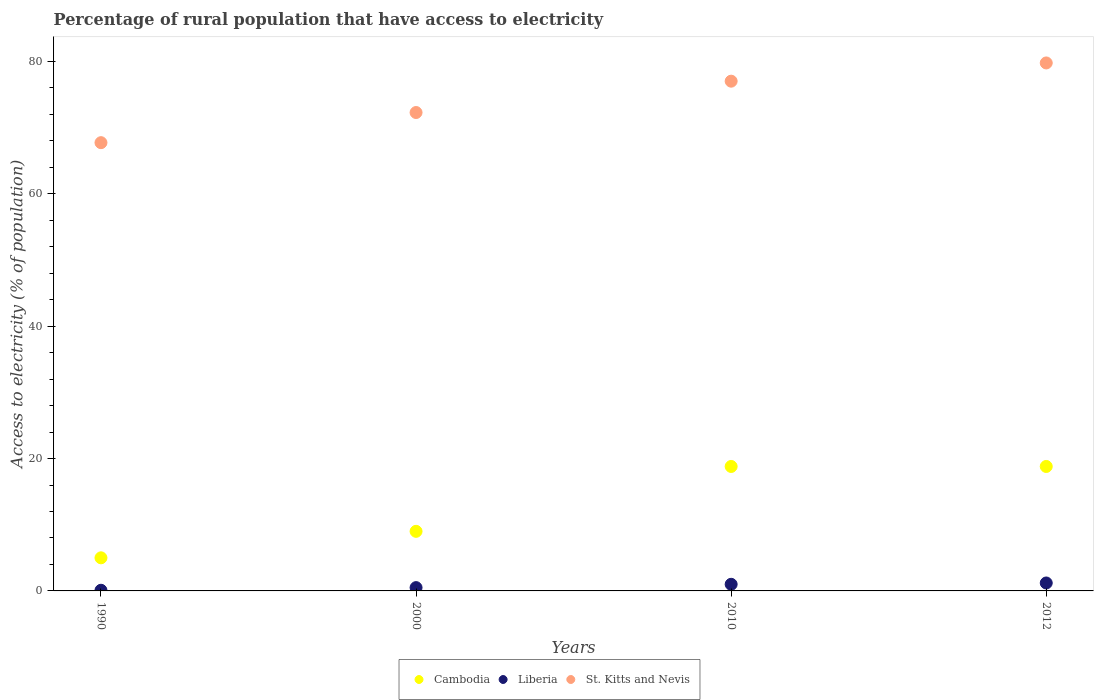How many different coloured dotlines are there?
Ensure brevity in your answer.  3. Across all years, what is the minimum percentage of rural population that have access to electricity in Liberia?
Your answer should be very brief. 0.1. In which year was the percentage of rural population that have access to electricity in Cambodia maximum?
Offer a very short reply. 2010. What is the total percentage of rural population that have access to electricity in St. Kitts and Nevis in the graph?
Your answer should be very brief. 296.73. What is the difference between the percentage of rural population that have access to electricity in St. Kitts and Nevis in 1990 and that in 2010?
Make the answer very short. -9.29. What is the difference between the percentage of rural population that have access to electricity in Cambodia in 1990 and the percentage of rural population that have access to electricity in St. Kitts and Nevis in 2000?
Your answer should be very brief. -67.27. What is the average percentage of rural population that have access to electricity in St. Kitts and Nevis per year?
Give a very brief answer. 74.18. In the year 2010, what is the difference between the percentage of rural population that have access to electricity in Liberia and percentage of rural population that have access to electricity in Cambodia?
Your answer should be compact. -17.8. In how many years, is the percentage of rural population that have access to electricity in Cambodia greater than 72 %?
Offer a terse response. 0. Is the difference between the percentage of rural population that have access to electricity in Liberia in 1990 and 2012 greater than the difference between the percentage of rural population that have access to electricity in Cambodia in 1990 and 2012?
Provide a short and direct response. Yes. What is the difference between the highest and the lowest percentage of rural population that have access to electricity in St. Kitts and Nevis?
Ensure brevity in your answer.  12.04. Does the percentage of rural population that have access to electricity in Cambodia monotonically increase over the years?
Give a very brief answer. No. Is the percentage of rural population that have access to electricity in Liberia strictly greater than the percentage of rural population that have access to electricity in St. Kitts and Nevis over the years?
Provide a succinct answer. No. Is the percentage of rural population that have access to electricity in Liberia strictly less than the percentage of rural population that have access to electricity in St. Kitts and Nevis over the years?
Ensure brevity in your answer.  Yes. Are the values on the major ticks of Y-axis written in scientific E-notation?
Offer a very short reply. No. Does the graph contain grids?
Provide a short and direct response. No. Where does the legend appear in the graph?
Provide a succinct answer. Bottom center. What is the title of the graph?
Ensure brevity in your answer.  Percentage of rural population that have access to electricity. What is the label or title of the Y-axis?
Ensure brevity in your answer.  Access to electricity (% of population). What is the Access to electricity (% of population) of St. Kitts and Nevis in 1990?
Your answer should be compact. 67.71. What is the Access to electricity (% of population) of St. Kitts and Nevis in 2000?
Make the answer very short. 72.27. What is the Access to electricity (% of population) in Cambodia in 2010?
Provide a succinct answer. 18.8. What is the Access to electricity (% of population) in Liberia in 2010?
Offer a very short reply. 1. What is the Access to electricity (% of population) of St. Kitts and Nevis in 2010?
Your response must be concise. 77. What is the Access to electricity (% of population) in Cambodia in 2012?
Provide a succinct answer. 18.8. What is the Access to electricity (% of population) in St. Kitts and Nevis in 2012?
Provide a succinct answer. 79.75. Across all years, what is the maximum Access to electricity (% of population) in St. Kitts and Nevis?
Ensure brevity in your answer.  79.75. Across all years, what is the minimum Access to electricity (% of population) of Cambodia?
Provide a succinct answer. 5. Across all years, what is the minimum Access to electricity (% of population) in Liberia?
Give a very brief answer. 0.1. Across all years, what is the minimum Access to electricity (% of population) in St. Kitts and Nevis?
Make the answer very short. 67.71. What is the total Access to electricity (% of population) in Cambodia in the graph?
Provide a short and direct response. 51.6. What is the total Access to electricity (% of population) of Liberia in the graph?
Make the answer very short. 2.8. What is the total Access to electricity (% of population) of St. Kitts and Nevis in the graph?
Give a very brief answer. 296.73. What is the difference between the Access to electricity (% of population) in Liberia in 1990 and that in 2000?
Your answer should be very brief. -0.4. What is the difference between the Access to electricity (% of population) of St. Kitts and Nevis in 1990 and that in 2000?
Keep it short and to the point. -4.55. What is the difference between the Access to electricity (% of population) of Liberia in 1990 and that in 2010?
Offer a terse response. -0.9. What is the difference between the Access to electricity (% of population) of St. Kitts and Nevis in 1990 and that in 2010?
Your answer should be compact. -9.29. What is the difference between the Access to electricity (% of population) in Cambodia in 1990 and that in 2012?
Make the answer very short. -13.8. What is the difference between the Access to electricity (% of population) in Liberia in 1990 and that in 2012?
Your response must be concise. -1.1. What is the difference between the Access to electricity (% of population) in St. Kitts and Nevis in 1990 and that in 2012?
Offer a terse response. -12.04. What is the difference between the Access to electricity (% of population) of Cambodia in 2000 and that in 2010?
Your response must be concise. -9.8. What is the difference between the Access to electricity (% of population) in Liberia in 2000 and that in 2010?
Provide a succinct answer. -0.5. What is the difference between the Access to electricity (% of population) in St. Kitts and Nevis in 2000 and that in 2010?
Your answer should be very brief. -4.74. What is the difference between the Access to electricity (% of population) of Cambodia in 2000 and that in 2012?
Offer a terse response. -9.8. What is the difference between the Access to electricity (% of population) in St. Kitts and Nevis in 2000 and that in 2012?
Your answer should be compact. -7.49. What is the difference between the Access to electricity (% of population) in Liberia in 2010 and that in 2012?
Provide a short and direct response. -0.2. What is the difference between the Access to electricity (% of population) in St. Kitts and Nevis in 2010 and that in 2012?
Your answer should be compact. -2.75. What is the difference between the Access to electricity (% of population) of Cambodia in 1990 and the Access to electricity (% of population) of St. Kitts and Nevis in 2000?
Your answer should be compact. -67.27. What is the difference between the Access to electricity (% of population) in Liberia in 1990 and the Access to electricity (% of population) in St. Kitts and Nevis in 2000?
Offer a terse response. -72.17. What is the difference between the Access to electricity (% of population) of Cambodia in 1990 and the Access to electricity (% of population) of St. Kitts and Nevis in 2010?
Keep it short and to the point. -72. What is the difference between the Access to electricity (% of population) in Liberia in 1990 and the Access to electricity (% of population) in St. Kitts and Nevis in 2010?
Your response must be concise. -76.9. What is the difference between the Access to electricity (% of population) of Cambodia in 1990 and the Access to electricity (% of population) of Liberia in 2012?
Your response must be concise. 3.8. What is the difference between the Access to electricity (% of population) of Cambodia in 1990 and the Access to electricity (% of population) of St. Kitts and Nevis in 2012?
Provide a short and direct response. -74.75. What is the difference between the Access to electricity (% of population) of Liberia in 1990 and the Access to electricity (% of population) of St. Kitts and Nevis in 2012?
Offer a terse response. -79.65. What is the difference between the Access to electricity (% of population) in Cambodia in 2000 and the Access to electricity (% of population) in Liberia in 2010?
Ensure brevity in your answer.  8. What is the difference between the Access to electricity (% of population) in Cambodia in 2000 and the Access to electricity (% of population) in St. Kitts and Nevis in 2010?
Give a very brief answer. -68. What is the difference between the Access to electricity (% of population) of Liberia in 2000 and the Access to electricity (% of population) of St. Kitts and Nevis in 2010?
Your answer should be compact. -76.5. What is the difference between the Access to electricity (% of population) of Cambodia in 2000 and the Access to electricity (% of population) of Liberia in 2012?
Keep it short and to the point. 7.8. What is the difference between the Access to electricity (% of population) of Cambodia in 2000 and the Access to electricity (% of population) of St. Kitts and Nevis in 2012?
Your response must be concise. -70.75. What is the difference between the Access to electricity (% of population) in Liberia in 2000 and the Access to electricity (% of population) in St. Kitts and Nevis in 2012?
Your answer should be compact. -79.25. What is the difference between the Access to electricity (% of population) of Cambodia in 2010 and the Access to electricity (% of population) of St. Kitts and Nevis in 2012?
Your answer should be compact. -60.95. What is the difference between the Access to electricity (% of population) in Liberia in 2010 and the Access to electricity (% of population) in St. Kitts and Nevis in 2012?
Your answer should be very brief. -78.75. What is the average Access to electricity (% of population) in Cambodia per year?
Keep it short and to the point. 12.9. What is the average Access to electricity (% of population) of Liberia per year?
Ensure brevity in your answer.  0.7. What is the average Access to electricity (% of population) of St. Kitts and Nevis per year?
Keep it short and to the point. 74.18. In the year 1990, what is the difference between the Access to electricity (% of population) of Cambodia and Access to electricity (% of population) of St. Kitts and Nevis?
Your response must be concise. -62.71. In the year 1990, what is the difference between the Access to electricity (% of population) of Liberia and Access to electricity (% of population) of St. Kitts and Nevis?
Your answer should be very brief. -67.61. In the year 2000, what is the difference between the Access to electricity (% of population) in Cambodia and Access to electricity (% of population) in Liberia?
Offer a very short reply. 8.5. In the year 2000, what is the difference between the Access to electricity (% of population) in Cambodia and Access to electricity (% of population) in St. Kitts and Nevis?
Give a very brief answer. -63.27. In the year 2000, what is the difference between the Access to electricity (% of population) in Liberia and Access to electricity (% of population) in St. Kitts and Nevis?
Your answer should be very brief. -71.77. In the year 2010, what is the difference between the Access to electricity (% of population) of Cambodia and Access to electricity (% of population) of St. Kitts and Nevis?
Your answer should be compact. -58.2. In the year 2010, what is the difference between the Access to electricity (% of population) of Liberia and Access to electricity (% of population) of St. Kitts and Nevis?
Provide a short and direct response. -76. In the year 2012, what is the difference between the Access to electricity (% of population) of Cambodia and Access to electricity (% of population) of Liberia?
Ensure brevity in your answer.  17.6. In the year 2012, what is the difference between the Access to electricity (% of population) of Cambodia and Access to electricity (% of population) of St. Kitts and Nevis?
Your answer should be compact. -60.95. In the year 2012, what is the difference between the Access to electricity (% of population) of Liberia and Access to electricity (% of population) of St. Kitts and Nevis?
Your answer should be very brief. -78.55. What is the ratio of the Access to electricity (% of population) of Cambodia in 1990 to that in 2000?
Your answer should be very brief. 0.56. What is the ratio of the Access to electricity (% of population) in St. Kitts and Nevis in 1990 to that in 2000?
Offer a very short reply. 0.94. What is the ratio of the Access to electricity (% of population) of Cambodia in 1990 to that in 2010?
Make the answer very short. 0.27. What is the ratio of the Access to electricity (% of population) in Liberia in 1990 to that in 2010?
Provide a succinct answer. 0.1. What is the ratio of the Access to electricity (% of population) of St. Kitts and Nevis in 1990 to that in 2010?
Offer a terse response. 0.88. What is the ratio of the Access to electricity (% of population) of Cambodia in 1990 to that in 2012?
Keep it short and to the point. 0.27. What is the ratio of the Access to electricity (% of population) of Liberia in 1990 to that in 2012?
Provide a succinct answer. 0.08. What is the ratio of the Access to electricity (% of population) of St. Kitts and Nevis in 1990 to that in 2012?
Ensure brevity in your answer.  0.85. What is the ratio of the Access to electricity (% of population) of Cambodia in 2000 to that in 2010?
Your response must be concise. 0.48. What is the ratio of the Access to electricity (% of population) of St. Kitts and Nevis in 2000 to that in 2010?
Make the answer very short. 0.94. What is the ratio of the Access to electricity (% of population) of Cambodia in 2000 to that in 2012?
Your answer should be compact. 0.48. What is the ratio of the Access to electricity (% of population) of Liberia in 2000 to that in 2012?
Provide a short and direct response. 0.42. What is the ratio of the Access to electricity (% of population) in St. Kitts and Nevis in 2000 to that in 2012?
Keep it short and to the point. 0.91. What is the ratio of the Access to electricity (% of population) of St. Kitts and Nevis in 2010 to that in 2012?
Your response must be concise. 0.97. What is the difference between the highest and the second highest Access to electricity (% of population) of Cambodia?
Make the answer very short. 0. What is the difference between the highest and the second highest Access to electricity (% of population) in St. Kitts and Nevis?
Offer a terse response. 2.75. What is the difference between the highest and the lowest Access to electricity (% of population) of St. Kitts and Nevis?
Keep it short and to the point. 12.04. 